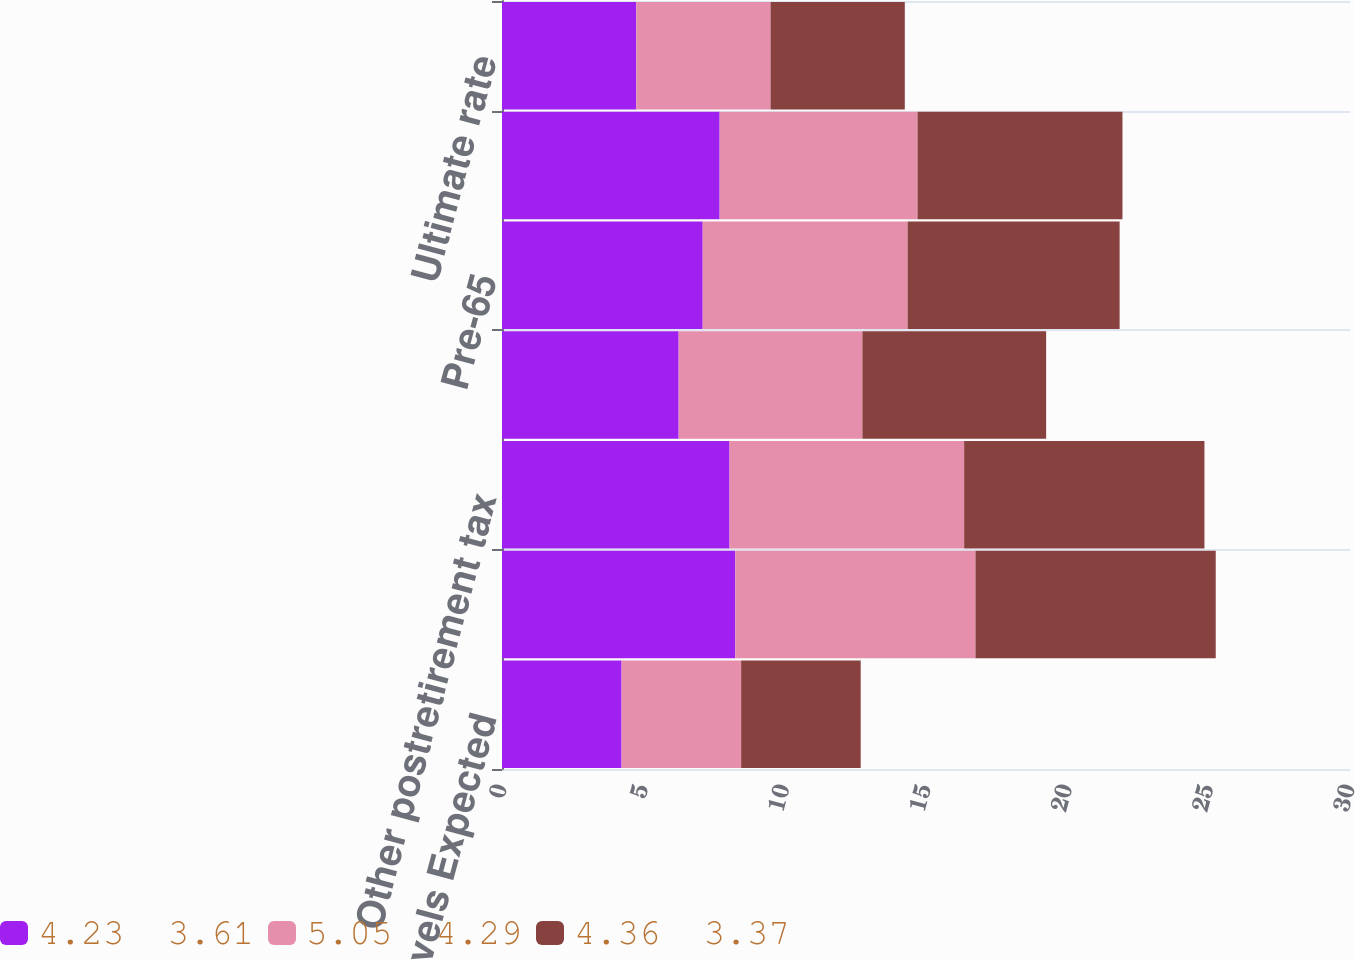Convert chart to OTSL. <chart><loc_0><loc_0><loc_500><loc_500><stacked_bar_chart><ecel><fcel>compensation levels Expected<fcel>assets Pension assets<fcel>Other postretirement tax<fcel>Other postretirement taxable<fcel>Pre-65<fcel>Post-65<fcel>Ultimate rate<nl><fcel>4.23  3.61<fcel>4.23<fcel>8.25<fcel>8.05<fcel>6.25<fcel>7.1<fcel>7.7<fcel>4.75<nl><fcel>5.05  4.29<fcel>4.23<fcel>8.5<fcel>8.3<fcel>6.5<fcel>7.25<fcel>7<fcel>4.75<nl><fcel>4.36  3.37<fcel>4.23<fcel>8.5<fcel>8.5<fcel>6.5<fcel>7.5<fcel>7.25<fcel>4.75<nl></chart> 